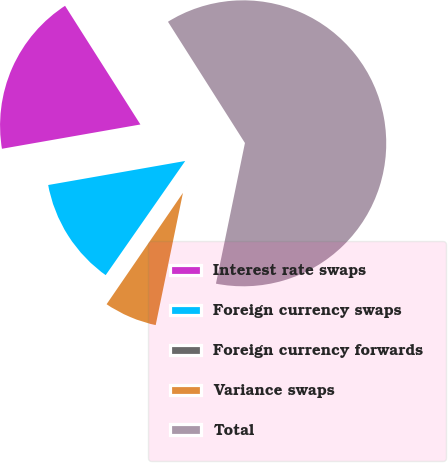Convert chart. <chart><loc_0><loc_0><loc_500><loc_500><pie_chart><fcel>Interest rate swaps<fcel>Foreign currency swaps<fcel>Foreign currency forwards<fcel>Variance swaps<fcel>Total<nl><fcel>18.76%<fcel>12.55%<fcel>0.12%<fcel>6.33%<fcel>62.24%<nl></chart> 